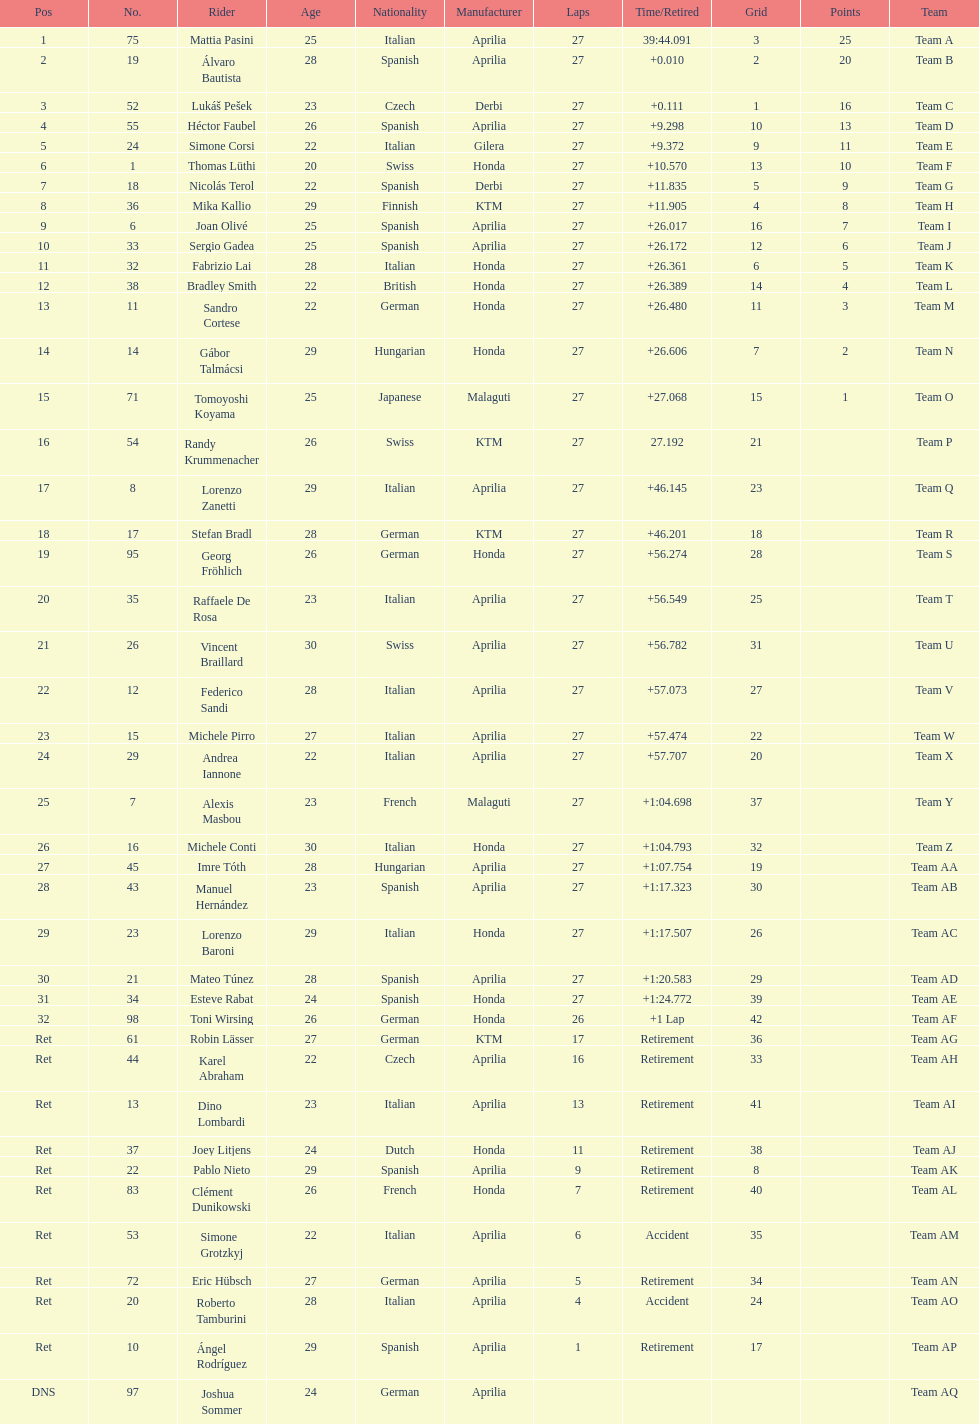What was the total number of positions in the 125cc classification? 43. 